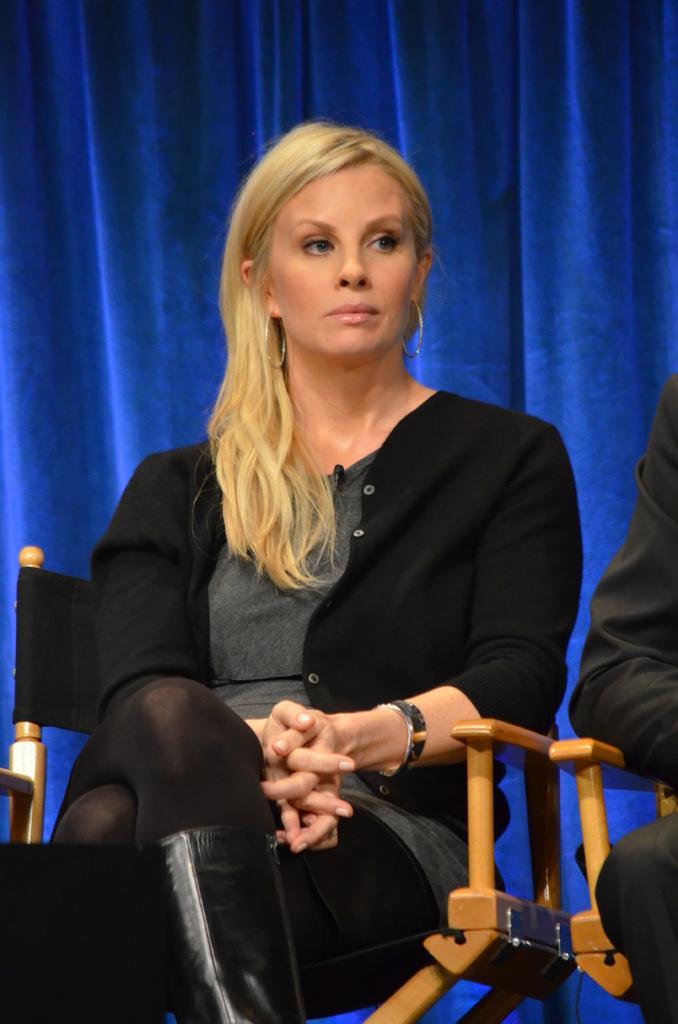Describe this image in one or two sentences. In this image, there are a few people sitting on chairs. We can also see an object on the bottom left corner. In the background, we can see some cloth. 